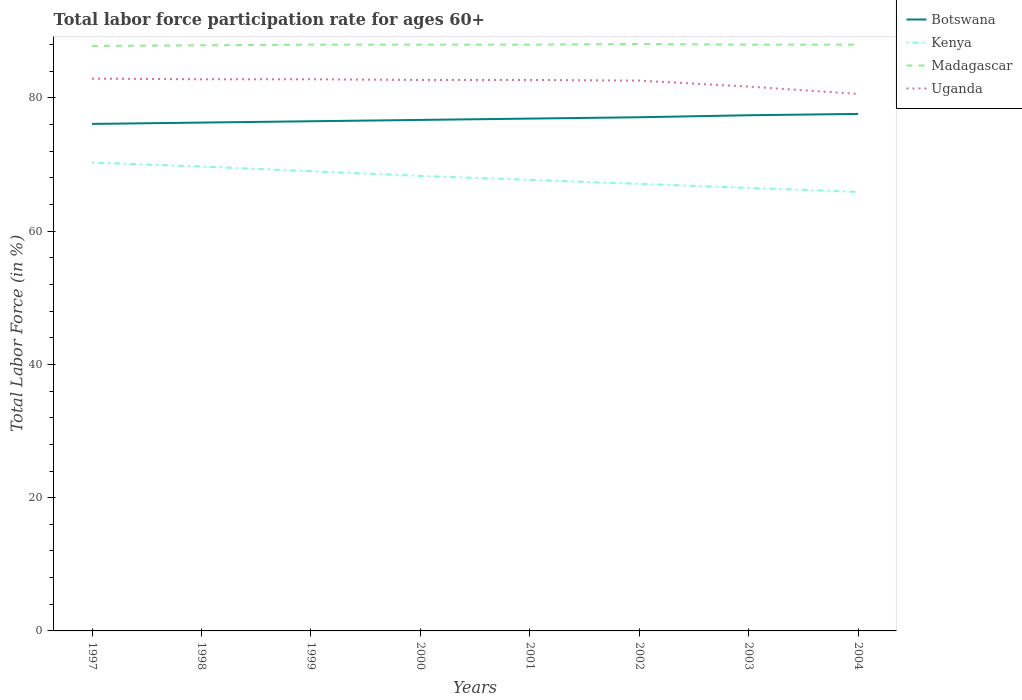Across all years, what is the maximum labor force participation rate in Botswana?
Give a very brief answer. 76.1. What is the total labor force participation rate in Botswana in the graph?
Your answer should be very brief. -0.6. What is the difference between the highest and the lowest labor force participation rate in Uganda?
Ensure brevity in your answer.  6. Is the labor force participation rate in Kenya strictly greater than the labor force participation rate in Botswana over the years?
Provide a short and direct response. Yes. How many years are there in the graph?
Make the answer very short. 8. What is the difference between two consecutive major ticks on the Y-axis?
Your answer should be very brief. 20. Are the values on the major ticks of Y-axis written in scientific E-notation?
Your answer should be compact. No. Does the graph contain any zero values?
Your answer should be compact. No. Does the graph contain grids?
Offer a terse response. No. Where does the legend appear in the graph?
Your response must be concise. Top right. How are the legend labels stacked?
Offer a terse response. Vertical. What is the title of the graph?
Offer a very short reply. Total labor force participation rate for ages 60+. What is the label or title of the X-axis?
Your response must be concise. Years. What is the label or title of the Y-axis?
Give a very brief answer. Total Labor Force (in %). What is the Total Labor Force (in %) of Botswana in 1997?
Make the answer very short. 76.1. What is the Total Labor Force (in %) in Kenya in 1997?
Provide a short and direct response. 70.3. What is the Total Labor Force (in %) in Madagascar in 1997?
Provide a succinct answer. 87.8. What is the Total Labor Force (in %) of Uganda in 1997?
Your answer should be very brief. 82.9. What is the Total Labor Force (in %) of Botswana in 1998?
Your answer should be very brief. 76.3. What is the Total Labor Force (in %) in Kenya in 1998?
Your answer should be very brief. 69.7. What is the Total Labor Force (in %) of Madagascar in 1998?
Ensure brevity in your answer.  87.9. What is the Total Labor Force (in %) of Uganda in 1998?
Keep it short and to the point. 82.8. What is the Total Labor Force (in %) of Botswana in 1999?
Offer a very short reply. 76.5. What is the Total Labor Force (in %) of Uganda in 1999?
Make the answer very short. 82.8. What is the Total Labor Force (in %) in Botswana in 2000?
Keep it short and to the point. 76.7. What is the Total Labor Force (in %) in Kenya in 2000?
Ensure brevity in your answer.  68.3. What is the Total Labor Force (in %) in Madagascar in 2000?
Offer a terse response. 88. What is the Total Labor Force (in %) in Uganda in 2000?
Ensure brevity in your answer.  82.7. What is the Total Labor Force (in %) in Botswana in 2001?
Make the answer very short. 76.9. What is the Total Labor Force (in %) of Kenya in 2001?
Ensure brevity in your answer.  67.7. What is the Total Labor Force (in %) of Uganda in 2001?
Provide a succinct answer. 82.7. What is the Total Labor Force (in %) in Botswana in 2002?
Give a very brief answer. 77.1. What is the Total Labor Force (in %) of Kenya in 2002?
Provide a succinct answer. 67.1. What is the Total Labor Force (in %) of Madagascar in 2002?
Your response must be concise. 88.1. What is the Total Labor Force (in %) of Uganda in 2002?
Give a very brief answer. 82.6. What is the Total Labor Force (in %) of Botswana in 2003?
Ensure brevity in your answer.  77.4. What is the Total Labor Force (in %) in Kenya in 2003?
Provide a short and direct response. 66.5. What is the Total Labor Force (in %) of Madagascar in 2003?
Keep it short and to the point. 88. What is the Total Labor Force (in %) in Uganda in 2003?
Offer a terse response. 81.7. What is the Total Labor Force (in %) in Botswana in 2004?
Offer a very short reply. 77.6. What is the Total Labor Force (in %) in Kenya in 2004?
Keep it short and to the point. 65.9. What is the Total Labor Force (in %) in Uganda in 2004?
Your answer should be compact. 80.6. Across all years, what is the maximum Total Labor Force (in %) of Botswana?
Provide a succinct answer. 77.6. Across all years, what is the maximum Total Labor Force (in %) of Kenya?
Keep it short and to the point. 70.3. Across all years, what is the maximum Total Labor Force (in %) in Madagascar?
Your answer should be very brief. 88.1. Across all years, what is the maximum Total Labor Force (in %) in Uganda?
Your response must be concise. 82.9. Across all years, what is the minimum Total Labor Force (in %) in Botswana?
Give a very brief answer. 76.1. Across all years, what is the minimum Total Labor Force (in %) in Kenya?
Your response must be concise. 65.9. Across all years, what is the minimum Total Labor Force (in %) in Madagascar?
Ensure brevity in your answer.  87.8. Across all years, what is the minimum Total Labor Force (in %) in Uganda?
Give a very brief answer. 80.6. What is the total Total Labor Force (in %) in Botswana in the graph?
Provide a short and direct response. 614.6. What is the total Total Labor Force (in %) in Kenya in the graph?
Offer a terse response. 544.5. What is the total Total Labor Force (in %) in Madagascar in the graph?
Your response must be concise. 703.8. What is the total Total Labor Force (in %) of Uganda in the graph?
Keep it short and to the point. 658.8. What is the difference between the Total Labor Force (in %) in Botswana in 1997 and that in 1998?
Offer a terse response. -0.2. What is the difference between the Total Labor Force (in %) in Kenya in 1997 and that in 1998?
Your answer should be very brief. 0.6. What is the difference between the Total Labor Force (in %) in Kenya in 1997 and that in 1999?
Your response must be concise. 1.3. What is the difference between the Total Labor Force (in %) of Madagascar in 1997 and that in 1999?
Make the answer very short. -0.2. What is the difference between the Total Labor Force (in %) in Uganda in 1997 and that in 1999?
Your answer should be compact. 0.1. What is the difference between the Total Labor Force (in %) of Botswana in 1997 and that in 2000?
Ensure brevity in your answer.  -0.6. What is the difference between the Total Labor Force (in %) in Madagascar in 1997 and that in 2000?
Keep it short and to the point. -0.2. What is the difference between the Total Labor Force (in %) of Botswana in 1997 and that in 2001?
Provide a short and direct response. -0.8. What is the difference between the Total Labor Force (in %) of Kenya in 1997 and that in 2001?
Provide a succinct answer. 2.6. What is the difference between the Total Labor Force (in %) of Uganda in 1997 and that in 2001?
Offer a terse response. 0.2. What is the difference between the Total Labor Force (in %) in Botswana in 1997 and that in 2002?
Your response must be concise. -1. What is the difference between the Total Labor Force (in %) in Madagascar in 1997 and that in 2002?
Provide a short and direct response. -0.3. What is the difference between the Total Labor Force (in %) of Madagascar in 1997 and that in 2003?
Offer a terse response. -0.2. What is the difference between the Total Labor Force (in %) in Uganda in 1997 and that in 2003?
Provide a succinct answer. 1.2. What is the difference between the Total Labor Force (in %) in Botswana in 1998 and that in 1999?
Your answer should be very brief. -0.2. What is the difference between the Total Labor Force (in %) of Uganda in 1998 and that in 1999?
Ensure brevity in your answer.  0. What is the difference between the Total Labor Force (in %) in Botswana in 1998 and that in 2000?
Provide a succinct answer. -0.4. What is the difference between the Total Labor Force (in %) of Kenya in 1998 and that in 2000?
Make the answer very short. 1.4. What is the difference between the Total Labor Force (in %) in Madagascar in 1998 and that in 2000?
Make the answer very short. -0.1. What is the difference between the Total Labor Force (in %) of Uganda in 1998 and that in 2000?
Offer a very short reply. 0.1. What is the difference between the Total Labor Force (in %) in Botswana in 1998 and that in 2001?
Your answer should be compact. -0.6. What is the difference between the Total Labor Force (in %) of Uganda in 1998 and that in 2001?
Give a very brief answer. 0.1. What is the difference between the Total Labor Force (in %) in Kenya in 1998 and that in 2002?
Offer a terse response. 2.6. What is the difference between the Total Labor Force (in %) in Uganda in 1998 and that in 2003?
Your answer should be compact. 1.1. What is the difference between the Total Labor Force (in %) in Kenya in 1998 and that in 2004?
Give a very brief answer. 3.8. What is the difference between the Total Labor Force (in %) of Madagascar in 1998 and that in 2004?
Your response must be concise. -0.1. What is the difference between the Total Labor Force (in %) of Madagascar in 1999 and that in 2000?
Ensure brevity in your answer.  0. What is the difference between the Total Labor Force (in %) in Uganda in 1999 and that in 2000?
Provide a short and direct response. 0.1. What is the difference between the Total Labor Force (in %) of Botswana in 1999 and that in 2001?
Offer a very short reply. -0.4. What is the difference between the Total Labor Force (in %) in Madagascar in 1999 and that in 2001?
Keep it short and to the point. 0. What is the difference between the Total Labor Force (in %) of Madagascar in 1999 and that in 2002?
Your answer should be compact. -0.1. What is the difference between the Total Labor Force (in %) of Kenya in 1999 and that in 2003?
Make the answer very short. 2.5. What is the difference between the Total Labor Force (in %) of Uganda in 1999 and that in 2003?
Your answer should be very brief. 1.1. What is the difference between the Total Labor Force (in %) in Kenya in 1999 and that in 2004?
Offer a very short reply. 3.1. What is the difference between the Total Labor Force (in %) of Madagascar in 1999 and that in 2004?
Keep it short and to the point. 0. What is the difference between the Total Labor Force (in %) in Uganda in 1999 and that in 2004?
Your response must be concise. 2.2. What is the difference between the Total Labor Force (in %) of Madagascar in 2000 and that in 2001?
Make the answer very short. 0. What is the difference between the Total Labor Force (in %) of Botswana in 2000 and that in 2002?
Your answer should be very brief. -0.4. What is the difference between the Total Labor Force (in %) in Kenya in 2000 and that in 2002?
Give a very brief answer. 1.2. What is the difference between the Total Labor Force (in %) in Kenya in 2000 and that in 2003?
Your answer should be very brief. 1.8. What is the difference between the Total Labor Force (in %) in Botswana in 2000 and that in 2004?
Give a very brief answer. -0.9. What is the difference between the Total Labor Force (in %) of Madagascar in 2000 and that in 2004?
Ensure brevity in your answer.  0. What is the difference between the Total Labor Force (in %) of Uganda in 2000 and that in 2004?
Give a very brief answer. 2.1. What is the difference between the Total Labor Force (in %) of Botswana in 2001 and that in 2002?
Offer a terse response. -0.2. What is the difference between the Total Labor Force (in %) in Kenya in 2001 and that in 2002?
Your response must be concise. 0.6. What is the difference between the Total Labor Force (in %) in Madagascar in 2001 and that in 2002?
Your response must be concise. -0.1. What is the difference between the Total Labor Force (in %) in Uganda in 2001 and that in 2002?
Ensure brevity in your answer.  0.1. What is the difference between the Total Labor Force (in %) in Botswana in 2001 and that in 2003?
Make the answer very short. -0.5. What is the difference between the Total Labor Force (in %) in Kenya in 2001 and that in 2004?
Ensure brevity in your answer.  1.8. What is the difference between the Total Labor Force (in %) in Uganda in 2001 and that in 2004?
Your answer should be very brief. 2.1. What is the difference between the Total Labor Force (in %) in Botswana in 2002 and that in 2003?
Ensure brevity in your answer.  -0.3. What is the difference between the Total Labor Force (in %) in Madagascar in 2002 and that in 2003?
Give a very brief answer. 0.1. What is the difference between the Total Labor Force (in %) in Uganda in 2002 and that in 2003?
Make the answer very short. 0.9. What is the difference between the Total Labor Force (in %) of Botswana in 2002 and that in 2004?
Make the answer very short. -0.5. What is the difference between the Total Labor Force (in %) in Madagascar in 2002 and that in 2004?
Provide a succinct answer. 0.1. What is the difference between the Total Labor Force (in %) of Botswana in 2003 and that in 2004?
Your answer should be very brief. -0.2. What is the difference between the Total Labor Force (in %) of Kenya in 2003 and that in 2004?
Give a very brief answer. 0.6. What is the difference between the Total Labor Force (in %) of Uganda in 2003 and that in 2004?
Give a very brief answer. 1.1. What is the difference between the Total Labor Force (in %) in Botswana in 1997 and the Total Labor Force (in %) in Madagascar in 1998?
Keep it short and to the point. -11.8. What is the difference between the Total Labor Force (in %) in Kenya in 1997 and the Total Labor Force (in %) in Madagascar in 1998?
Ensure brevity in your answer.  -17.6. What is the difference between the Total Labor Force (in %) of Kenya in 1997 and the Total Labor Force (in %) of Uganda in 1998?
Provide a succinct answer. -12.5. What is the difference between the Total Labor Force (in %) in Madagascar in 1997 and the Total Labor Force (in %) in Uganda in 1998?
Offer a terse response. 5. What is the difference between the Total Labor Force (in %) of Botswana in 1997 and the Total Labor Force (in %) of Madagascar in 1999?
Your answer should be compact. -11.9. What is the difference between the Total Labor Force (in %) of Kenya in 1997 and the Total Labor Force (in %) of Madagascar in 1999?
Give a very brief answer. -17.7. What is the difference between the Total Labor Force (in %) of Madagascar in 1997 and the Total Labor Force (in %) of Uganda in 1999?
Make the answer very short. 5. What is the difference between the Total Labor Force (in %) of Botswana in 1997 and the Total Labor Force (in %) of Madagascar in 2000?
Offer a very short reply. -11.9. What is the difference between the Total Labor Force (in %) in Botswana in 1997 and the Total Labor Force (in %) in Uganda in 2000?
Make the answer very short. -6.6. What is the difference between the Total Labor Force (in %) of Kenya in 1997 and the Total Labor Force (in %) of Madagascar in 2000?
Your response must be concise. -17.7. What is the difference between the Total Labor Force (in %) of Madagascar in 1997 and the Total Labor Force (in %) of Uganda in 2000?
Your answer should be very brief. 5.1. What is the difference between the Total Labor Force (in %) in Botswana in 1997 and the Total Labor Force (in %) in Madagascar in 2001?
Give a very brief answer. -11.9. What is the difference between the Total Labor Force (in %) of Botswana in 1997 and the Total Labor Force (in %) of Uganda in 2001?
Your answer should be very brief. -6.6. What is the difference between the Total Labor Force (in %) in Kenya in 1997 and the Total Labor Force (in %) in Madagascar in 2001?
Your answer should be very brief. -17.7. What is the difference between the Total Labor Force (in %) in Botswana in 1997 and the Total Labor Force (in %) in Madagascar in 2002?
Your answer should be very brief. -12. What is the difference between the Total Labor Force (in %) in Botswana in 1997 and the Total Labor Force (in %) in Uganda in 2002?
Offer a terse response. -6.5. What is the difference between the Total Labor Force (in %) of Kenya in 1997 and the Total Labor Force (in %) of Madagascar in 2002?
Provide a short and direct response. -17.8. What is the difference between the Total Labor Force (in %) in Kenya in 1997 and the Total Labor Force (in %) in Uganda in 2002?
Make the answer very short. -12.3. What is the difference between the Total Labor Force (in %) in Madagascar in 1997 and the Total Labor Force (in %) in Uganda in 2002?
Your answer should be very brief. 5.2. What is the difference between the Total Labor Force (in %) of Botswana in 1997 and the Total Labor Force (in %) of Kenya in 2003?
Give a very brief answer. 9.6. What is the difference between the Total Labor Force (in %) of Botswana in 1997 and the Total Labor Force (in %) of Uganda in 2003?
Your response must be concise. -5.6. What is the difference between the Total Labor Force (in %) of Kenya in 1997 and the Total Labor Force (in %) of Madagascar in 2003?
Make the answer very short. -17.7. What is the difference between the Total Labor Force (in %) of Madagascar in 1997 and the Total Labor Force (in %) of Uganda in 2003?
Your response must be concise. 6.1. What is the difference between the Total Labor Force (in %) in Botswana in 1997 and the Total Labor Force (in %) in Madagascar in 2004?
Provide a short and direct response. -11.9. What is the difference between the Total Labor Force (in %) in Botswana in 1997 and the Total Labor Force (in %) in Uganda in 2004?
Provide a succinct answer. -4.5. What is the difference between the Total Labor Force (in %) in Kenya in 1997 and the Total Labor Force (in %) in Madagascar in 2004?
Your answer should be compact. -17.7. What is the difference between the Total Labor Force (in %) in Kenya in 1997 and the Total Labor Force (in %) in Uganda in 2004?
Make the answer very short. -10.3. What is the difference between the Total Labor Force (in %) in Madagascar in 1997 and the Total Labor Force (in %) in Uganda in 2004?
Keep it short and to the point. 7.2. What is the difference between the Total Labor Force (in %) in Botswana in 1998 and the Total Labor Force (in %) in Kenya in 1999?
Ensure brevity in your answer.  7.3. What is the difference between the Total Labor Force (in %) of Botswana in 1998 and the Total Labor Force (in %) of Madagascar in 1999?
Ensure brevity in your answer.  -11.7. What is the difference between the Total Labor Force (in %) of Kenya in 1998 and the Total Labor Force (in %) of Madagascar in 1999?
Give a very brief answer. -18.3. What is the difference between the Total Labor Force (in %) in Kenya in 1998 and the Total Labor Force (in %) in Madagascar in 2000?
Provide a short and direct response. -18.3. What is the difference between the Total Labor Force (in %) of Madagascar in 1998 and the Total Labor Force (in %) of Uganda in 2000?
Provide a succinct answer. 5.2. What is the difference between the Total Labor Force (in %) in Botswana in 1998 and the Total Labor Force (in %) in Kenya in 2001?
Give a very brief answer. 8.6. What is the difference between the Total Labor Force (in %) of Botswana in 1998 and the Total Labor Force (in %) of Madagascar in 2001?
Provide a short and direct response. -11.7. What is the difference between the Total Labor Force (in %) in Botswana in 1998 and the Total Labor Force (in %) in Uganda in 2001?
Give a very brief answer. -6.4. What is the difference between the Total Labor Force (in %) in Kenya in 1998 and the Total Labor Force (in %) in Madagascar in 2001?
Provide a short and direct response. -18.3. What is the difference between the Total Labor Force (in %) in Kenya in 1998 and the Total Labor Force (in %) in Uganda in 2001?
Make the answer very short. -13. What is the difference between the Total Labor Force (in %) of Botswana in 1998 and the Total Labor Force (in %) of Kenya in 2002?
Your response must be concise. 9.2. What is the difference between the Total Labor Force (in %) in Botswana in 1998 and the Total Labor Force (in %) in Madagascar in 2002?
Your answer should be very brief. -11.8. What is the difference between the Total Labor Force (in %) of Kenya in 1998 and the Total Labor Force (in %) of Madagascar in 2002?
Provide a succinct answer. -18.4. What is the difference between the Total Labor Force (in %) of Kenya in 1998 and the Total Labor Force (in %) of Uganda in 2002?
Your response must be concise. -12.9. What is the difference between the Total Labor Force (in %) in Madagascar in 1998 and the Total Labor Force (in %) in Uganda in 2002?
Offer a very short reply. 5.3. What is the difference between the Total Labor Force (in %) in Botswana in 1998 and the Total Labor Force (in %) in Madagascar in 2003?
Your answer should be compact. -11.7. What is the difference between the Total Labor Force (in %) of Kenya in 1998 and the Total Labor Force (in %) of Madagascar in 2003?
Your response must be concise. -18.3. What is the difference between the Total Labor Force (in %) of Kenya in 1998 and the Total Labor Force (in %) of Uganda in 2003?
Give a very brief answer. -12. What is the difference between the Total Labor Force (in %) in Botswana in 1998 and the Total Labor Force (in %) in Kenya in 2004?
Ensure brevity in your answer.  10.4. What is the difference between the Total Labor Force (in %) in Botswana in 1998 and the Total Labor Force (in %) in Madagascar in 2004?
Your answer should be very brief. -11.7. What is the difference between the Total Labor Force (in %) in Botswana in 1998 and the Total Labor Force (in %) in Uganda in 2004?
Your answer should be very brief. -4.3. What is the difference between the Total Labor Force (in %) in Kenya in 1998 and the Total Labor Force (in %) in Madagascar in 2004?
Offer a terse response. -18.3. What is the difference between the Total Labor Force (in %) in Madagascar in 1998 and the Total Labor Force (in %) in Uganda in 2004?
Provide a short and direct response. 7.3. What is the difference between the Total Labor Force (in %) of Kenya in 1999 and the Total Labor Force (in %) of Madagascar in 2000?
Ensure brevity in your answer.  -19. What is the difference between the Total Labor Force (in %) of Kenya in 1999 and the Total Labor Force (in %) of Uganda in 2000?
Ensure brevity in your answer.  -13.7. What is the difference between the Total Labor Force (in %) of Madagascar in 1999 and the Total Labor Force (in %) of Uganda in 2000?
Give a very brief answer. 5.3. What is the difference between the Total Labor Force (in %) in Botswana in 1999 and the Total Labor Force (in %) in Kenya in 2001?
Your answer should be very brief. 8.8. What is the difference between the Total Labor Force (in %) in Kenya in 1999 and the Total Labor Force (in %) in Madagascar in 2001?
Make the answer very short. -19. What is the difference between the Total Labor Force (in %) in Kenya in 1999 and the Total Labor Force (in %) in Uganda in 2001?
Your response must be concise. -13.7. What is the difference between the Total Labor Force (in %) in Botswana in 1999 and the Total Labor Force (in %) in Kenya in 2002?
Offer a very short reply. 9.4. What is the difference between the Total Labor Force (in %) of Botswana in 1999 and the Total Labor Force (in %) of Madagascar in 2002?
Make the answer very short. -11.6. What is the difference between the Total Labor Force (in %) in Kenya in 1999 and the Total Labor Force (in %) in Madagascar in 2002?
Ensure brevity in your answer.  -19.1. What is the difference between the Total Labor Force (in %) of Madagascar in 1999 and the Total Labor Force (in %) of Uganda in 2002?
Your answer should be compact. 5.4. What is the difference between the Total Labor Force (in %) of Botswana in 1999 and the Total Labor Force (in %) of Kenya in 2003?
Your answer should be compact. 10. What is the difference between the Total Labor Force (in %) in Kenya in 1999 and the Total Labor Force (in %) in Uganda in 2003?
Your answer should be compact. -12.7. What is the difference between the Total Labor Force (in %) in Kenya in 1999 and the Total Labor Force (in %) in Madagascar in 2004?
Give a very brief answer. -19. What is the difference between the Total Labor Force (in %) of Madagascar in 1999 and the Total Labor Force (in %) of Uganda in 2004?
Make the answer very short. 7.4. What is the difference between the Total Labor Force (in %) of Botswana in 2000 and the Total Labor Force (in %) of Uganda in 2001?
Your answer should be very brief. -6. What is the difference between the Total Labor Force (in %) in Kenya in 2000 and the Total Labor Force (in %) in Madagascar in 2001?
Provide a succinct answer. -19.7. What is the difference between the Total Labor Force (in %) in Kenya in 2000 and the Total Labor Force (in %) in Uganda in 2001?
Keep it short and to the point. -14.4. What is the difference between the Total Labor Force (in %) in Madagascar in 2000 and the Total Labor Force (in %) in Uganda in 2001?
Provide a short and direct response. 5.3. What is the difference between the Total Labor Force (in %) in Botswana in 2000 and the Total Labor Force (in %) in Kenya in 2002?
Provide a short and direct response. 9.6. What is the difference between the Total Labor Force (in %) of Kenya in 2000 and the Total Labor Force (in %) of Madagascar in 2002?
Your answer should be very brief. -19.8. What is the difference between the Total Labor Force (in %) of Kenya in 2000 and the Total Labor Force (in %) of Uganda in 2002?
Provide a succinct answer. -14.3. What is the difference between the Total Labor Force (in %) of Madagascar in 2000 and the Total Labor Force (in %) of Uganda in 2002?
Offer a terse response. 5.4. What is the difference between the Total Labor Force (in %) in Botswana in 2000 and the Total Labor Force (in %) in Uganda in 2003?
Offer a very short reply. -5. What is the difference between the Total Labor Force (in %) in Kenya in 2000 and the Total Labor Force (in %) in Madagascar in 2003?
Give a very brief answer. -19.7. What is the difference between the Total Labor Force (in %) of Madagascar in 2000 and the Total Labor Force (in %) of Uganda in 2003?
Make the answer very short. 6.3. What is the difference between the Total Labor Force (in %) of Botswana in 2000 and the Total Labor Force (in %) of Madagascar in 2004?
Provide a short and direct response. -11.3. What is the difference between the Total Labor Force (in %) in Botswana in 2000 and the Total Labor Force (in %) in Uganda in 2004?
Your answer should be very brief. -3.9. What is the difference between the Total Labor Force (in %) of Kenya in 2000 and the Total Labor Force (in %) of Madagascar in 2004?
Provide a short and direct response. -19.7. What is the difference between the Total Labor Force (in %) in Kenya in 2000 and the Total Labor Force (in %) in Uganda in 2004?
Your response must be concise. -12.3. What is the difference between the Total Labor Force (in %) in Madagascar in 2000 and the Total Labor Force (in %) in Uganda in 2004?
Your answer should be compact. 7.4. What is the difference between the Total Labor Force (in %) in Botswana in 2001 and the Total Labor Force (in %) in Uganda in 2002?
Offer a very short reply. -5.7. What is the difference between the Total Labor Force (in %) in Kenya in 2001 and the Total Labor Force (in %) in Madagascar in 2002?
Give a very brief answer. -20.4. What is the difference between the Total Labor Force (in %) in Kenya in 2001 and the Total Labor Force (in %) in Uganda in 2002?
Give a very brief answer. -14.9. What is the difference between the Total Labor Force (in %) in Botswana in 2001 and the Total Labor Force (in %) in Kenya in 2003?
Give a very brief answer. 10.4. What is the difference between the Total Labor Force (in %) of Botswana in 2001 and the Total Labor Force (in %) of Madagascar in 2003?
Make the answer very short. -11.1. What is the difference between the Total Labor Force (in %) in Kenya in 2001 and the Total Labor Force (in %) in Madagascar in 2003?
Offer a very short reply. -20.3. What is the difference between the Total Labor Force (in %) in Botswana in 2001 and the Total Labor Force (in %) in Kenya in 2004?
Provide a short and direct response. 11. What is the difference between the Total Labor Force (in %) in Kenya in 2001 and the Total Labor Force (in %) in Madagascar in 2004?
Give a very brief answer. -20.3. What is the difference between the Total Labor Force (in %) in Madagascar in 2001 and the Total Labor Force (in %) in Uganda in 2004?
Provide a succinct answer. 7.4. What is the difference between the Total Labor Force (in %) of Botswana in 2002 and the Total Labor Force (in %) of Kenya in 2003?
Your response must be concise. 10.6. What is the difference between the Total Labor Force (in %) of Botswana in 2002 and the Total Labor Force (in %) of Madagascar in 2003?
Your answer should be very brief. -10.9. What is the difference between the Total Labor Force (in %) of Botswana in 2002 and the Total Labor Force (in %) of Uganda in 2003?
Offer a terse response. -4.6. What is the difference between the Total Labor Force (in %) of Kenya in 2002 and the Total Labor Force (in %) of Madagascar in 2003?
Provide a succinct answer. -20.9. What is the difference between the Total Labor Force (in %) in Kenya in 2002 and the Total Labor Force (in %) in Uganda in 2003?
Your answer should be compact. -14.6. What is the difference between the Total Labor Force (in %) of Madagascar in 2002 and the Total Labor Force (in %) of Uganda in 2003?
Your answer should be compact. 6.4. What is the difference between the Total Labor Force (in %) in Botswana in 2002 and the Total Labor Force (in %) in Kenya in 2004?
Your response must be concise. 11.2. What is the difference between the Total Labor Force (in %) of Botswana in 2002 and the Total Labor Force (in %) of Madagascar in 2004?
Ensure brevity in your answer.  -10.9. What is the difference between the Total Labor Force (in %) in Kenya in 2002 and the Total Labor Force (in %) in Madagascar in 2004?
Offer a very short reply. -20.9. What is the difference between the Total Labor Force (in %) of Kenya in 2002 and the Total Labor Force (in %) of Uganda in 2004?
Ensure brevity in your answer.  -13.5. What is the difference between the Total Labor Force (in %) in Madagascar in 2002 and the Total Labor Force (in %) in Uganda in 2004?
Your answer should be compact. 7.5. What is the difference between the Total Labor Force (in %) of Botswana in 2003 and the Total Labor Force (in %) of Uganda in 2004?
Your response must be concise. -3.2. What is the difference between the Total Labor Force (in %) of Kenya in 2003 and the Total Labor Force (in %) of Madagascar in 2004?
Your response must be concise. -21.5. What is the difference between the Total Labor Force (in %) of Kenya in 2003 and the Total Labor Force (in %) of Uganda in 2004?
Provide a short and direct response. -14.1. What is the difference between the Total Labor Force (in %) of Madagascar in 2003 and the Total Labor Force (in %) of Uganda in 2004?
Provide a succinct answer. 7.4. What is the average Total Labor Force (in %) in Botswana per year?
Your answer should be compact. 76.83. What is the average Total Labor Force (in %) of Kenya per year?
Provide a succinct answer. 68.06. What is the average Total Labor Force (in %) in Madagascar per year?
Offer a very short reply. 87.97. What is the average Total Labor Force (in %) in Uganda per year?
Offer a very short reply. 82.35. In the year 1997, what is the difference between the Total Labor Force (in %) in Botswana and Total Labor Force (in %) in Madagascar?
Give a very brief answer. -11.7. In the year 1997, what is the difference between the Total Labor Force (in %) of Botswana and Total Labor Force (in %) of Uganda?
Your answer should be very brief. -6.8. In the year 1997, what is the difference between the Total Labor Force (in %) in Kenya and Total Labor Force (in %) in Madagascar?
Your answer should be very brief. -17.5. In the year 1997, what is the difference between the Total Labor Force (in %) in Kenya and Total Labor Force (in %) in Uganda?
Your answer should be very brief. -12.6. In the year 1998, what is the difference between the Total Labor Force (in %) of Botswana and Total Labor Force (in %) of Kenya?
Your response must be concise. 6.6. In the year 1998, what is the difference between the Total Labor Force (in %) of Botswana and Total Labor Force (in %) of Madagascar?
Ensure brevity in your answer.  -11.6. In the year 1998, what is the difference between the Total Labor Force (in %) in Botswana and Total Labor Force (in %) in Uganda?
Ensure brevity in your answer.  -6.5. In the year 1998, what is the difference between the Total Labor Force (in %) of Kenya and Total Labor Force (in %) of Madagascar?
Offer a very short reply. -18.2. In the year 1998, what is the difference between the Total Labor Force (in %) of Kenya and Total Labor Force (in %) of Uganda?
Keep it short and to the point. -13.1. In the year 1998, what is the difference between the Total Labor Force (in %) of Madagascar and Total Labor Force (in %) of Uganda?
Provide a short and direct response. 5.1. In the year 1999, what is the difference between the Total Labor Force (in %) of Kenya and Total Labor Force (in %) of Madagascar?
Your answer should be compact. -19. In the year 1999, what is the difference between the Total Labor Force (in %) in Kenya and Total Labor Force (in %) in Uganda?
Offer a very short reply. -13.8. In the year 2000, what is the difference between the Total Labor Force (in %) in Kenya and Total Labor Force (in %) in Madagascar?
Give a very brief answer. -19.7. In the year 2000, what is the difference between the Total Labor Force (in %) of Kenya and Total Labor Force (in %) of Uganda?
Provide a short and direct response. -14.4. In the year 2001, what is the difference between the Total Labor Force (in %) in Botswana and Total Labor Force (in %) in Madagascar?
Give a very brief answer. -11.1. In the year 2001, what is the difference between the Total Labor Force (in %) in Kenya and Total Labor Force (in %) in Madagascar?
Ensure brevity in your answer.  -20.3. In the year 2001, what is the difference between the Total Labor Force (in %) in Kenya and Total Labor Force (in %) in Uganda?
Make the answer very short. -15. In the year 2002, what is the difference between the Total Labor Force (in %) in Botswana and Total Labor Force (in %) in Kenya?
Provide a succinct answer. 10. In the year 2002, what is the difference between the Total Labor Force (in %) of Botswana and Total Labor Force (in %) of Madagascar?
Your answer should be very brief. -11. In the year 2002, what is the difference between the Total Labor Force (in %) of Botswana and Total Labor Force (in %) of Uganda?
Your response must be concise. -5.5. In the year 2002, what is the difference between the Total Labor Force (in %) of Kenya and Total Labor Force (in %) of Madagascar?
Make the answer very short. -21. In the year 2002, what is the difference between the Total Labor Force (in %) of Kenya and Total Labor Force (in %) of Uganda?
Your response must be concise. -15.5. In the year 2002, what is the difference between the Total Labor Force (in %) in Madagascar and Total Labor Force (in %) in Uganda?
Make the answer very short. 5.5. In the year 2003, what is the difference between the Total Labor Force (in %) in Kenya and Total Labor Force (in %) in Madagascar?
Provide a succinct answer. -21.5. In the year 2003, what is the difference between the Total Labor Force (in %) of Kenya and Total Labor Force (in %) of Uganda?
Your answer should be very brief. -15.2. In the year 2004, what is the difference between the Total Labor Force (in %) in Botswana and Total Labor Force (in %) in Kenya?
Provide a succinct answer. 11.7. In the year 2004, what is the difference between the Total Labor Force (in %) in Kenya and Total Labor Force (in %) in Madagascar?
Ensure brevity in your answer.  -22.1. In the year 2004, what is the difference between the Total Labor Force (in %) of Kenya and Total Labor Force (in %) of Uganda?
Your answer should be compact. -14.7. What is the ratio of the Total Labor Force (in %) in Botswana in 1997 to that in 1998?
Ensure brevity in your answer.  1. What is the ratio of the Total Labor Force (in %) in Kenya in 1997 to that in 1998?
Offer a terse response. 1.01. What is the ratio of the Total Labor Force (in %) in Uganda in 1997 to that in 1998?
Give a very brief answer. 1. What is the ratio of the Total Labor Force (in %) of Botswana in 1997 to that in 1999?
Give a very brief answer. 0.99. What is the ratio of the Total Labor Force (in %) in Kenya in 1997 to that in 1999?
Provide a succinct answer. 1.02. What is the ratio of the Total Labor Force (in %) in Madagascar in 1997 to that in 1999?
Provide a succinct answer. 1. What is the ratio of the Total Labor Force (in %) of Uganda in 1997 to that in 1999?
Ensure brevity in your answer.  1. What is the ratio of the Total Labor Force (in %) in Kenya in 1997 to that in 2000?
Your answer should be compact. 1.03. What is the ratio of the Total Labor Force (in %) of Madagascar in 1997 to that in 2000?
Provide a succinct answer. 1. What is the ratio of the Total Labor Force (in %) in Kenya in 1997 to that in 2001?
Keep it short and to the point. 1.04. What is the ratio of the Total Labor Force (in %) of Madagascar in 1997 to that in 2001?
Your response must be concise. 1. What is the ratio of the Total Labor Force (in %) of Botswana in 1997 to that in 2002?
Your answer should be compact. 0.99. What is the ratio of the Total Labor Force (in %) in Kenya in 1997 to that in 2002?
Your answer should be compact. 1.05. What is the ratio of the Total Labor Force (in %) in Madagascar in 1997 to that in 2002?
Your answer should be compact. 1. What is the ratio of the Total Labor Force (in %) of Botswana in 1997 to that in 2003?
Provide a succinct answer. 0.98. What is the ratio of the Total Labor Force (in %) in Kenya in 1997 to that in 2003?
Provide a succinct answer. 1.06. What is the ratio of the Total Labor Force (in %) in Madagascar in 1997 to that in 2003?
Your answer should be very brief. 1. What is the ratio of the Total Labor Force (in %) of Uganda in 1997 to that in 2003?
Keep it short and to the point. 1.01. What is the ratio of the Total Labor Force (in %) of Botswana in 1997 to that in 2004?
Make the answer very short. 0.98. What is the ratio of the Total Labor Force (in %) of Kenya in 1997 to that in 2004?
Provide a succinct answer. 1.07. What is the ratio of the Total Labor Force (in %) of Uganda in 1997 to that in 2004?
Offer a terse response. 1.03. What is the ratio of the Total Labor Force (in %) in Botswana in 1998 to that in 1999?
Offer a very short reply. 1. What is the ratio of the Total Labor Force (in %) in Madagascar in 1998 to that in 1999?
Provide a short and direct response. 1. What is the ratio of the Total Labor Force (in %) of Kenya in 1998 to that in 2000?
Provide a short and direct response. 1.02. What is the ratio of the Total Labor Force (in %) of Madagascar in 1998 to that in 2000?
Give a very brief answer. 1. What is the ratio of the Total Labor Force (in %) in Uganda in 1998 to that in 2000?
Offer a terse response. 1. What is the ratio of the Total Labor Force (in %) of Botswana in 1998 to that in 2001?
Your answer should be compact. 0.99. What is the ratio of the Total Labor Force (in %) in Kenya in 1998 to that in 2001?
Keep it short and to the point. 1.03. What is the ratio of the Total Labor Force (in %) of Madagascar in 1998 to that in 2001?
Keep it short and to the point. 1. What is the ratio of the Total Labor Force (in %) of Uganda in 1998 to that in 2001?
Provide a short and direct response. 1. What is the ratio of the Total Labor Force (in %) in Botswana in 1998 to that in 2002?
Give a very brief answer. 0.99. What is the ratio of the Total Labor Force (in %) in Kenya in 1998 to that in 2002?
Your response must be concise. 1.04. What is the ratio of the Total Labor Force (in %) in Botswana in 1998 to that in 2003?
Give a very brief answer. 0.99. What is the ratio of the Total Labor Force (in %) of Kenya in 1998 to that in 2003?
Ensure brevity in your answer.  1.05. What is the ratio of the Total Labor Force (in %) of Uganda in 1998 to that in 2003?
Offer a terse response. 1.01. What is the ratio of the Total Labor Force (in %) in Botswana in 1998 to that in 2004?
Make the answer very short. 0.98. What is the ratio of the Total Labor Force (in %) of Kenya in 1998 to that in 2004?
Offer a very short reply. 1.06. What is the ratio of the Total Labor Force (in %) of Madagascar in 1998 to that in 2004?
Your answer should be compact. 1. What is the ratio of the Total Labor Force (in %) in Uganda in 1998 to that in 2004?
Make the answer very short. 1.03. What is the ratio of the Total Labor Force (in %) in Botswana in 1999 to that in 2000?
Provide a succinct answer. 1. What is the ratio of the Total Labor Force (in %) in Kenya in 1999 to that in 2000?
Ensure brevity in your answer.  1.01. What is the ratio of the Total Labor Force (in %) of Botswana in 1999 to that in 2001?
Provide a succinct answer. 0.99. What is the ratio of the Total Labor Force (in %) of Kenya in 1999 to that in 2001?
Ensure brevity in your answer.  1.02. What is the ratio of the Total Labor Force (in %) of Uganda in 1999 to that in 2001?
Keep it short and to the point. 1. What is the ratio of the Total Labor Force (in %) of Kenya in 1999 to that in 2002?
Give a very brief answer. 1.03. What is the ratio of the Total Labor Force (in %) in Madagascar in 1999 to that in 2002?
Make the answer very short. 1. What is the ratio of the Total Labor Force (in %) of Uganda in 1999 to that in 2002?
Give a very brief answer. 1. What is the ratio of the Total Labor Force (in %) in Botswana in 1999 to that in 2003?
Your answer should be compact. 0.99. What is the ratio of the Total Labor Force (in %) in Kenya in 1999 to that in 2003?
Make the answer very short. 1.04. What is the ratio of the Total Labor Force (in %) in Uganda in 1999 to that in 2003?
Your response must be concise. 1.01. What is the ratio of the Total Labor Force (in %) in Botswana in 1999 to that in 2004?
Offer a very short reply. 0.99. What is the ratio of the Total Labor Force (in %) in Kenya in 1999 to that in 2004?
Keep it short and to the point. 1.05. What is the ratio of the Total Labor Force (in %) of Madagascar in 1999 to that in 2004?
Make the answer very short. 1. What is the ratio of the Total Labor Force (in %) in Uganda in 1999 to that in 2004?
Ensure brevity in your answer.  1.03. What is the ratio of the Total Labor Force (in %) of Kenya in 2000 to that in 2001?
Offer a very short reply. 1.01. What is the ratio of the Total Labor Force (in %) of Madagascar in 2000 to that in 2001?
Ensure brevity in your answer.  1. What is the ratio of the Total Labor Force (in %) in Uganda in 2000 to that in 2001?
Your response must be concise. 1. What is the ratio of the Total Labor Force (in %) of Kenya in 2000 to that in 2002?
Your answer should be compact. 1.02. What is the ratio of the Total Labor Force (in %) of Madagascar in 2000 to that in 2002?
Your response must be concise. 1. What is the ratio of the Total Labor Force (in %) of Botswana in 2000 to that in 2003?
Offer a terse response. 0.99. What is the ratio of the Total Labor Force (in %) in Kenya in 2000 to that in 2003?
Your answer should be very brief. 1.03. What is the ratio of the Total Labor Force (in %) in Madagascar in 2000 to that in 2003?
Keep it short and to the point. 1. What is the ratio of the Total Labor Force (in %) in Uganda in 2000 to that in 2003?
Keep it short and to the point. 1.01. What is the ratio of the Total Labor Force (in %) of Botswana in 2000 to that in 2004?
Your answer should be very brief. 0.99. What is the ratio of the Total Labor Force (in %) of Kenya in 2000 to that in 2004?
Make the answer very short. 1.04. What is the ratio of the Total Labor Force (in %) of Madagascar in 2000 to that in 2004?
Provide a short and direct response. 1. What is the ratio of the Total Labor Force (in %) of Uganda in 2000 to that in 2004?
Provide a short and direct response. 1.03. What is the ratio of the Total Labor Force (in %) in Botswana in 2001 to that in 2002?
Make the answer very short. 1. What is the ratio of the Total Labor Force (in %) in Kenya in 2001 to that in 2002?
Ensure brevity in your answer.  1.01. What is the ratio of the Total Labor Force (in %) of Madagascar in 2001 to that in 2002?
Ensure brevity in your answer.  1. What is the ratio of the Total Labor Force (in %) of Uganda in 2001 to that in 2002?
Keep it short and to the point. 1. What is the ratio of the Total Labor Force (in %) in Botswana in 2001 to that in 2003?
Make the answer very short. 0.99. What is the ratio of the Total Labor Force (in %) in Kenya in 2001 to that in 2003?
Your answer should be very brief. 1.02. What is the ratio of the Total Labor Force (in %) of Uganda in 2001 to that in 2003?
Offer a terse response. 1.01. What is the ratio of the Total Labor Force (in %) of Botswana in 2001 to that in 2004?
Ensure brevity in your answer.  0.99. What is the ratio of the Total Labor Force (in %) of Kenya in 2001 to that in 2004?
Offer a terse response. 1.03. What is the ratio of the Total Labor Force (in %) of Madagascar in 2001 to that in 2004?
Provide a succinct answer. 1. What is the ratio of the Total Labor Force (in %) of Uganda in 2001 to that in 2004?
Give a very brief answer. 1.03. What is the ratio of the Total Labor Force (in %) of Botswana in 2002 to that in 2003?
Provide a short and direct response. 1. What is the ratio of the Total Labor Force (in %) in Uganda in 2002 to that in 2003?
Keep it short and to the point. 1.01. What is the ratio of the Total Labor Force (in %) of Kenya in 2002 to that in 2004?
Your answer should be very brief. 1.02. What is the ratio of the Total Labor Force (in %) in Uganda in 2002 to that in 2004?
Offer a very short reply. 1.02. What is the ratio of the Total Labor Force (in %) in Kenya in 2003 to that in 2004?
Offer a very short reply. 1.01. What is the ratio of the Total Labor Force (in %) in Madagascar in 2003 to that in 2004?
Provide a short and direct response. 1. What is the ratio of the Total Labor Force (in %) of Uganda in 2003 to that in 2004?
Make the answer very short. 1.01. What is the difference between the highest and the second highest Total Labor Force (in %) of Botswana?
Provide a short and direct response. 0.2. What is the difference between the highest and the second highest Total Labor Force (in %) in Uganda?
Offer a very short reply. 0.1. What is the difference between the highest and the lowest Total Labor Force (in %) of Kenya?
Keep it short and to the point. 4.4. What is the difference between the highest and the lowest Total Labor Force (in %) of Madagascar?
Make the answer very short. 0.3. What is the difference between the highest and the lowest Total Labor Force (in %) of Uganda?
Provide a short and direct response. 2.3. 